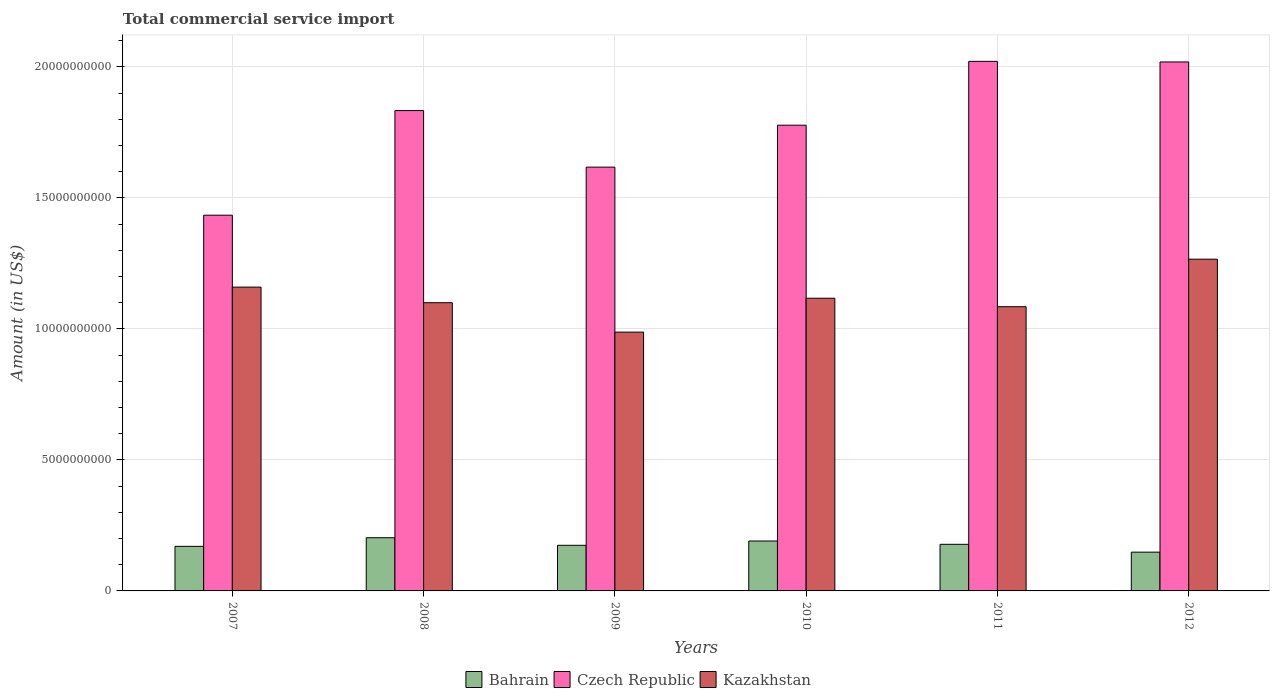How many different coloured bars are there?
Make the answer very short. 3. How many bars are there on the 3rd tick from the left?
Provide a short and direct response. 3. How many bars are there on the 4th tick from the right?
Provide a short and direct response. 3. What is the total commercial service import in Bahrain in 2007?
Provide a succinct answer. 1.70e+09. Across all years, what is the maximum total commercial service import in Czech Republic?
Your answer should be compact. 2.02e+1. Across all years, what is the minimum total commercial service import in Kazakhstan?
Provide a short and direct response. 9.88e+09. In which year was the total commercial service import in Czech Republic maximum?
Your response must be concise. 2011. In which year was the total commercial service import in Bahrain minimum?
Offer a very short reply. 2012. What is the total total commercial service import in Czech Republic in the graph?
Make the answer very short. 1.07e+11. What is the difference between the total commercial service import in Kazakhstan in 2008 and that in 2010?
Your answer should be compact. -1.71e+08. What is the difference between the total commercial service import in Kazakhstan in 2008 and the total commercial service import in Bahrain in 2009?
Your answer should be compact. 9.26e+09. What is the average total commercial service import in Kazakhstan per year?
Provide a short and direct response. 1.12e+1. In the year 2007, what is the difference between the total commercial service import in Czech Republic and total commercial service import in Kazakhstan?
Offer a very short reply. 2.75e+09. What is the ratio of the total commercial service import in Bahrain in 2008 to that in 2012?
Your response must be concise. 1.37. Is the total commercial service import in Kazakhstan in 2007 less than that in 2009?
Keep it short and to the point. No. What is the difference between the highest and the second highest total commercial service import in Bahrain?
Provide a succinct answer. 1.25e+08. What is the difference between the highest and the lowest total commercial service import in Kazakhstan?
Your answer should be compact. 2.78e+09. In how many years, is the total commercial service import in Bahrain greater than the average total commercial service import in Bahrain taken over all years?
Ensure brevity in your answer.  3. What does the 2nd bar from the left in 2010 represents?
Offer a very short reply. Czech Republic. What does the 1st bar from the right in 2012 represents?
Your answer should be compact. Kazakhstan. How many years are there in the graph?
Make the answer very short. 6. Are the values on the major ticks of Y-axis written in scientific E-notation?
Give a very brief answer. No. How many legend labels are there?
Your answer should be compact. 3. What is the title of the graph?
Give a very brief answer. Total commercial service import. Does "Nigeria" appear as one of the legend labels in the graph?
Your answer should be very brief. No. What is the label or title of the X-axis?
Make the answer very short. Years. What is the Amount (in US$) of Bahrain in 2007?
Give a very brief answer. 1.70e+09. What is the Amount (in US$) of Czech Republic in 2007?
Ensure brevity in your answer.  1.43e+1. What is the Amount (in US$) of Kazakhstan in 2007?
Make the answer very short. 1.16e+1. What is the Amount (in US$) in Bahrain in 2008?
Your answer should be compact. 2.03e+09. What is the Amount (in US$) in Czech Republic in 2008?
Offer a terse response. 1.83e+1. What is the Amount (in US$) in Kazakhstan in 2008?
Your answer should be compact. 1.10e+1. What is the Amount (in US$) in Bahrain in 2009?
Provide a short and direct response. 1.74e+09. What is the Amount (in US$) in Czech Republic in 2009?
Your response must be concise. 1.62e+1. What is the Amount (in US$) of Kazakhstan in 2009?
Your answer should be very brief. 9.88e+09. What is the Amount (in US$) in Bahrain in 2010?
Your response must be concise. 1.91e+09. What is the Amount (in US$) in Czech Republic in 2010?
Offer a terse response. 1.78e+1. What is the Amount (in US$) in Kazakhstan in 2010?
Keep it short and to the point. 1.12e+1. What is the Amount (in US$) of Bahrain in 2011?
Offer a terse response. 1.78e+09. What is the Amount (in US$) in Czech Republic in 2011?
Your response must be concise. 2.02e+1. What is the Amount (in US$) of Kazakhstan in 2011?
Provide a succinct answer. 1.08e+1. What is the Amount (in US$) of Bahrain in 2012?
Your answer should be very brief. 1.48e+09. What is the Amount (in US$) of Czech Republic in 2012?
Your answer should be very brief. 2.02e+1. What is the Amount (in US$) in Kazakhstan in 2012?
Offer a terse response. 1.27e+1. Across all years, what is the maximum Amount (in US$) in Bahrain?
Provide a succinct answer. 2.03e+09. Across all years, what is the maximum Amount (in US$) of Czech Republic?
Your answer should be compact. 2.02e+1. Across all years, what is the maximum Amount (in US$) in Kazakhstan?
Keep it short and to the point. 1.27e+1. Across all years, what is the minimum Amount (in US$) of Bahrain?
Your answer should be compact. 1.48e+09. Across all years, what is the minimum Amount (in US$) in Czech Republic?
Provide a succinct answer. 1.43e+1. Across all years, what is the minimum Amount (in US$) of Kazakhstan?
Your response must be concise. 9.88e+09. What is the total Amount (in US$) of Bahrain in the graph?
Ensure brevity in your answer.  1.06e+1. What is the total Amount (in US$) in Czech Republic in the graph?
Give a very brief answer. 1.07e+11. What is the total Amount (in US$) of Kazakhstan in the graph?
Offer a very short reply. 6.72e+1. What is the difference between the Amount (in US$) in Bahrain in 2007 and that in 2008?
Your answer should be compact. -3.29e+08. What is the difference between the Amount (in US$) in Czech Republic in 2007 and that in 2008?
Your answer should be very brief. -3.99e+09. What is the difference between the Amount (in US$) of Kazakhstan in 2007 and that in 2008?
Offer a terse response. 5.95e+08. What is the difference between the Amount (in US$) in Bahrain in 2007 and that in 2009?
Ensure brevity in your answer.  -4.00e+07. What is the difference between the Amount (in US$) of Czech Republic in 2007 and that in 2009?
Provide a succinct answer. -1.83e+09. What is the difference between the Amount (in US$) of Kazakhstan in 2007 and that in 2009?
Give a very brief answer. 1.72e+09. What is the difference between the Amount (in US$) of Bahrain in 2007 and that in 2010?
Give a very brief answer. -2.04e+08. What is the difference between the Amount (in US$) of Czech Republic in 2007 and that in 2010?
Ensure brevity in your answer.  -3.43e+09. What is the difference between the Amount (in US$) in Kazakhstan in 2007 and that in 2010?
Make the answer very short. 4.24e+08. What is the difference between the Amount (in US$) of Bahrain in 2007 and that in 2011?
Provide a short and direct response. -7.75e+07. What is the difference between the Amount (in US$) in Czech Republic in 2007 and that in 2011?
Your answer should be very brief. -5.87e+09. What is the difference between the Amount (in US$) of Kazakhstan in 2007 and that in 2011?
Your answer should be compact. 7.47e+08. What is the difference between the Amount (in US$) in Bahrain in 2007 and that in 2012?
Offer a terse response. 2.21e+08. What is the difference between the Amount (in US$) in Czech Republic in 2007 and that in 2012?
Provide a succinct answer. -5.85e+09. What is the difference between the Amount (in US$) of Kazakhstan in 2007 and that in 2012?
Ensure brevity in your answer.  -1.07e+09. What is the difference between the Amount (in US$) in Bahrain in 2008 and that in 2009?
Provide a short and direct response. 2.89e+08. What is the difference between the Amount (in US$) of Czech Republic in 2008 and that in 2009?
Your response must be concise. 2.16e+09. What is the difference between the Amount (in US$) in Kazakhstan in 2008 and that in 2009?
Give a very brief answer. 1.12e+09. What is the difference between the Amount (in US$) of Bahrain in 2008 and that in 2010?
Provide a short and direct response. 1.25e+08. What is the difference between the Amount (in US$) of Czech Republic in 2008 and that in 2010?
Your answer should be very brief. 5.58e+08. What is the difference between the Amount (in US$) in Kazakhstan in 2008 and that in 2010?
Make the answer very short. -1.71e+08. What is the difference between the Amount (in US$) of Bahrain in 2008 and that in 2011?
Your response must be concise. 2.52e+08. What is the difference between the Amount (in US$) in Czech Republic in 2008 and that in 2011?
Offer a terse response. -1.88e+09. What is the difference between the Amount (in US$) of Kazakhstan in 2008 and that in 2011?
Your response must be concise. 1.52e+08. What is the difference between the Amount (in US$) in Bahrain in 2008 and that in 2012?
Your answer should be compact. 5.50e+08. What is the difference between the Amount (in US$) of Czech Republic in 2008 and that in 2012?
Keep it short and to the point. -1.86e+09. What is the difference between the Amount (in US$) of Kazakhstan in 2008 and that in 2012?
Offer a very short reply. -1.66e+09. What is the difference between the Amount (in US$) in Bahrain in 2009 and that in 2010?
Provide a succinct answer. -1.64e+08. What is the difference between the Amount (in US$) in Czech Republic in 2009 and that in 2010?
Make the answer very short. -1.60e+09. What is the difference between the Amount (in US$) in Kazakhstan in 2009 and that in 2010?
Provide a succinct answer. -1.29e+09. What is the difference between the Amount (in US$) in Bahrain in 2009 and that in 2011?
Your response must be concise. -3.75e+07. What is the difference between the Amount (in US$) in Czech Republic in 2009 and that in 2011?
Make the answer very short. -4.04e+09. What is the difference between the Amount (in US$) in Kazakhstan in 2009 and that in 2011?
Offer a terse response. -9.71e+08. What is the difference between the Amount (in US$) in Bahrain in 2009 and that in 2012?
Make the answer very short. 2.61e+08. What is the difference between the Amount (in US$) of Czech Republic in 2009 and that in 2012?
Offer a terse response. -4.01e+09. What is the difference between the Amount (in US$) of Kazakhstan in 2009 and that in 2012?
Give a very brief answer. -2.78e+09. What is the difference between the Amount (in US$) of Bahrain in 2010 and that in 2011?
Your response must be concise. 1.27e+08. What is the difference between the Amount (in US$) in Czech Republic in 2010 and that in 2011?
Give a very brief answer. -2.44e+09. What is the difference between the Amount (in US$) in Kazakhstan in 2010 and that in 2011?
Your response must be concise. 3.23e+08. What is the difference between the Amount (in US$) in Bahrain in 2010 and that in 2012?
Make the answer very short. 4.25e+08. What is the difference between the Amount (in US$) in Czech Republic in 2010 and that in 2012?
Give a very brief answer. -2.41e+09. What is the difference between the Amount (in US$) in Kazakhstan in 2010 and that in 2012?
Your answer should be very brief. -1.49e+09. What is the difference between the Amount (in US$) in Bahrain in 2011 and that in 2012?
Offer a very short reply. 2.98e+08. What is the difference between the Amount (in US$) of Czech Republic in 2011 and that in 2012?
Give a very brief answer. 2.30e+07. What is the difference between the Amount (in US$) of Kazakhstan in 2011 and that in 2012?
Your response must be concise. -1.81e+09. What is the difference between the Amount (in US$) of Bahrain in 2007 and the Amount (in US$) of Czech Republic in 2008?
Your answer should be very brief. -1.66e+1. What is the difference between the Amount (in US$) in Bahrain in 2007 and the Amount (in US$) in Kazakhstan in 2008?
Your answer should be compact. -9.30e+09. What is the difference between the Amount (in US$) of Czech Republic in 2007 and the Amount (in US$) of Kazakhstan in 2008?
Make the answer very short. 3.34e+09. What is the difference between the Amount (in US$) in Bahrain in 2007 and the Amount (in US$) in Czech Republic in 2009?
Keep it short and to the point. -1.45e+1. What is the difference between the Amount (in US$) in Bahrain in 2007 and the Amount (in US$) in Kazakhstan in 2009?
Give a very brief answer. -8.18e+09. What is the difference between the Amount (in US$) in Czech Republic in 2007 and the Amount (in US$) in Kazakhstan in 2009?
Make the answer very short. 4.46e+09. What is the difference between the Amount (in US$) in Bahrain in 2007 and the Amount (in US$) in Czech Republic in 2010?
Offer a terse response. -1.61e+1. What is the difference between the Amount (in US$) of Bahrain in 2007 and the Amount (in US$) of Kazakhstan in 2010?
Keep it short and to the point. -9.47e+09. What is the difference between the Amount (in US$) in Czech Republic in 2007 and the Amount (in US$) in Kazakhstan in 2010?
Keep it short and to the point. 3.17e+09. What is the difference between the Amount (in US$) in Bahrain in 2007 and the Amount (in US$) in Czech Republic in 2011?
Give a very brief answer. -1.85e+1. What is the difference between the Amount (in US$) of Bahrain in 2007 and the Amount (in US$) of Kazakhstan in 2011?
Your answer should be very brief. -9.15e+09. What is the difference between the Amount (in US$) of Czech Republic in 2007 and the Amount (in US$) of Kazakhstan in 2011?
Ensure brevity in your answer.  3.49e+09. What is the difference between the Amount (in US$) of Bahrain in 2007 and the Amount (in US$) of Czech Republic in 2012?
Your response must be concise. -1.85e+1. What is the difference between the Amount (in US$) of Bahrain in 2007 and the Amount (in US$) of Kazakhstan in 2012?
Your response must be concise. -1.10e+1. What is the difference between the Amount (in US$) in Czech Republic in 2007 and the Amount (in US$) in Kazakhstan in 2012?
Keep it short and to the point. 1.68e+09. What is the difference between the Amount (in US$) in Bahrain in 2008 and the Amount (in US$) in Czech Republic in 2009?
Your answer should be very brief. -1.41e+1. What is the difference between the Amount (in US$) of Bahrain in 2008 and the Amount (in US$) of Kazakhstan in 2009?
Provide a succinct answer. -7.85e+09. What is the difference between the Amount (in US$) of Czech Republic in 2008 and the Amount (in US$) of Kazakhstan in 2009?
Offer a very short reply. 8.46e+09. What is the difference between the Amount (in US$) of Bahrain in 2008 and the Amount (in US$) of Czech Republic in 2010?
Provide a short and direct response. -1.57e+1. What is the difference between the Amount (in US$) in Bahrain in 2008 and the Amount (in US$) in Kazakhstan in 2010?
Provide a short and direct response. -9.14e+09. What is the difference between the Amount (in US$) of Czech Republic in 2008 and the Amount (in US$) of Kazakhstan in 2010?
Offer a very short reply. 7.16e+09. What is the difference between the Amount (in US$) of Bahrain in 2008 and the Amount (in US$) of Czech Republic in 2011?
Provide a succinct answer. -1.82e+1. What is the difference between the Amount (in US$) in Bahrain in 2008 and the Amount (in US$) in Kazakhstan in 2011?
Provide a succinct answer. -8.82e+09. What is the difference between the Amount (in US$) of Czech Republic in 2008 and the Amount (in US$) of Kazakhstan in 2011?
Offer a very short reply. 7.49e+09. What is the difference between the Amount (in US$) of Bahrain in 2008 and the Amount (in US$) of Czech Republic in 2012?
Your response must be concise. -1.82e+1. What is the difference between the Amount (in US$) in Bahrain in 2008 and the Amount (in US$) in Kazakhstan in 2012?
Your response must be concise. -1.06e+1. What is the difference between the Amount (in US$) of Czech Republic in 2008 and the Amount (in US$) of Kazakhstan in 2012?
Your answer should be compact. 5.67e+09. What is the difference between the Amount (in US$) in Bahrain in 2009 and the Amount (in US$) in Czech Republic in 2010?
Your response must be concise. -1.60e+1. What is the difference between the Amount (in US$) in Bahrain in 2009 and the Amount (in US$) in Kazakhstan in 2010?
Keep it short and to the point. -9.43e+09. What is the difference between the Amount (in US$) in Czech Republic in 2009 and the Amount (in US$) in Kazakhstan in 2010?
Provide a short and direct response. 5.00e+09. What is the difference between the Amount (in US$) in Bahrain in 2009 and the Amount (in US$) in Czech Republic in 2011?
Make the answer very short. -1.85e+1. What is the difference between the Amount (in US$) of Bahrain in 2009 and the Amount (in US$) of Kazakhstan in 2011?
Provide a short and direct response. -9.11e+09. What is the difference between the Amount (in US$) of Czech Republic in 2009 and the Amount (in US$) of Kazakhstan in 2011?
Provide a succinct answer. 5.33e+09. What is the difference between the Amount (in US$) in Bahrain in 2009 and the Amount (in US$) in Czech Republic in 2012?
Offer a terse response. -1.84e+1. What is the difference between the Amount (in US$) of Bahrain in 2009 and the Amount (in US$) of Kazakhstan in 2012?
Your answer should be very brief. -1.09e+1. What is the difference between the Amount (in US$) in Czech Republic in 2009 and the Amount (in US$) in Kazakhstan in 2012?
Ensure brevity in your answer.  3.51e+09. What is the difference between the Amount (in US$) of Bahrain in 2010 and the Amount (in US$) of Czech Republic in 2011?
Offer a terse response. -1.83e+1. What is the difference between the Amount (in US$) in Bahrain in 2010 and the Amount (in US$) in Kazakhstan in 2011?
Your answer should be compact. -8.94e+09. What is the difference between the Amount (in US$) of Czech Republic in 2010 and the Amount (in US$) of Kazakhstan in 2011?
Offer a very short reply. 6.93e+09. What is the difference between the Amount (in US$) of Bahrain in 2010 and the Amount (in US$) of Czech Republic in 2012?
Make the answer very short. -1.83e+1. What is the difference between the Amount (in US$) of Bahrain in 2010 and the Amount (in US$) of Kazakhstan in 2012?
Offer a terse response. -1.08e+1. What is the difference between the Amount (in US$) in Czech Republic in 2010 and the Amount (in US$) in Kazakhstan in 2012?
Make the answer very short. 5.11e+09. What is the difference between the Amount (in US$) in Bahrain in 2011 and the Amount (in US$) in Czech Republic in 2012?
Offer a very short reply. -1.84e+1. What is the difference between the Amount (in US$) of Bahrain in 2011 and the Amount (in US$) of Kazakhstan in 2012?
Your response must be concise. -1.09e+1. What is the difference between the Amount (in US$) of Czech Republic in 2011 and the Amount (in US$) of Kazakhstan in 2012?
Provide a succinct answer. 7.55e+09. What is the average Amount (in US$) of Bahrain per year?
Offer a very short reply. 1.77e+09. What is the average Amount (in US$) of Czech Republic per year?
Offer a very short reply. 1.78e+1. What is the average Amount (in US$) of Kazakhstan per year?
Keep it short and to the point. 1.12e+1. In the year 2007, what is the difference between the Amount (in US$) of Bahrain and Amount (in US$) of Czech Republic?
Your response must be concise. -1.26e+1. In the year 2007, what is the difference between the Amount (in US$) of Bahrain and Amount (in US$) of Kazakhstan?
Keep it short and to the point. -9.89e+09. In the year 2007, what is the difference between the Amount (in US$) of Czech Republic and Amount (in US$) of Kazakhstan?
Ensure brevity in your answer.  2.75e+09. In the year 2008, what is the difference between the Amount (in US$) in Bahrain and Amount (in US$) in Czech Republic?
Your answer should be compact. -1.63e+1. In the year 2008, what is the difference between the Amount (in US$) in Bahrain and Amount (in US$) in Kazakhstan?
Your response must be concise. -8.97e+09. In the year 2008, what is the difference between the Amount (in US$) of Czech Republic and Amount (in US$) of Kazakhstan?
Offer a terse response. 7.33e+09. In the year 2009, what is the difference between the Amount (in US$) in Bahrain and Amount (in US$) in Czech Republic?
Ensure brevity in your answer.  -1.44e+1. In the year 2009, what is the difference between the Amount (in US$) in Bahrain and Amount (in US$) in Kazakhstan?
Your answer should be very brief. -8.14e+09. In the year 2009, what is the difference between the Amount (in US$) of Czech Republic and Amount (in US$) of Kazakhstan?
Keep it short and to the point. 6.30e+09. In the year 2010, what is the difference between the Amount (in US$) in Bahrain and Amount (in US$) in Czech Republic?
Your answer should be very brief. -1.59e+1. In the year 2010, what is the difference between the Amount (in US$) of Bahrain and Amount (in US$) of Kazakhstan?
Your response must be concise. -9.27e+09. In the year 2010, what is the difference between the Amount (in US$) in Czech Republic and Amount (in US$) in Kazakhstan?
Provide a succinct answer. 6.60e+09. In the year 2011, what is the difference between the Amount (in US$) of Bahrain and Amount (in US$) of Czech Republic?
Offer a very short reply. -1.84e+1. In the year 2011, what is the difference between the Amount (in US$) of Bahrain and Amount (in US$) of Kazakhstan?
Provide a succinct answer. -9.07e+09. In the year 2011, what is the difference between the Amount (in US$) in Czech Republic and Amount (in US$) in Kazakhstan?
Your answer should be compact. 9.36e+09. In the year 2012, what is the difference between the Amount (in US$) of Bahrain and Amount (in US$) of Czech Republic?
Provide a short and direct response. -1.87e+1. In the year 2012, what is the difference between the Amount (in US$) in Bahrain and Amount (in US$) in Kazakhstan?
Give a very brief answer. -1.12e+1. In the year 2012, what is the difference between the Amount (in US$) of Czech Republic and Amount (in US$) of Kazakhstan?
Your answer should be very brief. 7.53e+09. What is the ratio of the Amount (in US$) in Bahrain in 2007 to that in 2008?
Keep it short and to the point. 0.84. What is the ratio of the Amount (in US$) in Czech Republic in 2007 to that in 2008?
Give a very brief answer. 0.78. What is the ratio of the Amount (in US$) of Kazakhstan in 2007 to that in 2008?
Offer a very short reply. 1.05. What is the ratio of the Amount (in US$) of Czech Republic in 2007 to that in 2009?
Make the answer very short. 0.89. What is the ratio of the Amount (in US$) of Kazakhstan in 2007 to that in 2009?
Give a very brief answer. 1.17. What is the ratio of the Amount (in US$) in Bahrain in 2007 to that in 2010?
Provide a succinct answer. 0.89. What is the ratio of the Amount (in US$) of Czech Republic in 2007 to that in 2010?
Your answer should be compact. 0.81. What is the ratio of the Amount (in US$) in Kazakhstan in 2007 to that in 2010?
Your answer should be very brief. 1.04. What is the ratio of the Amount (in US$) in Bahrain in 2007 to that in 2011?
Ensure brevity in your answer.  0.96. What is the ratio of the Amount (in US$) of Czech Republic in 2007 to that in 2011?
Provide a succinct answer. 0.71. What is the ratio of the Amount (in US$) of Kazakhstan in 2007 to that in 2011?
Give a very brief answer. 1.07. What is the ratio of the Amount (in US$) in Bahrain in 2007 to that in 2012?
Provide a succinct answer. 1.15. What is the ratio of the Amount (in US$) of Czech Republic in 2007 to that in 2012?
Provide a short and direct response. 0.71. What is the ratio of the Amount (in US$) in Kazakhstan in 2007 to that in 2012?
Your response must be concise. 0.92. What is the ratio of the Amount (in US$) of Bahrain in 2008 to that in 2009?
Your answer should be very brief. 1.17. What is the ratio of the Amount (in US$) in Czech Republic in 2008 to that in 2009?
Give a very brief answer. 1.13. What is the ratio of the Amount (in US$) of Kazakhstan in 2008 to that in 2009?
Provide a succinct answer. 1.11. What is the ratio of the Amount (in US$) of Bahrain in 2008 to that in 2010?
Keep it short and to the point. 1.07. What is the ratio of the Amount (in US$) of Czech Republic in 2008 to that in 2010?
Provide a short and direct response. 1.03. What is the ratio of the Amount (in US$) in Kazakhstan in 2008 to that in 2010?
Give a very brief answer. 0.98. What is the ratio of the Amount (in US$) in Bahrain in 2008 to that in 2011?
Provide a short and direct response. 1.14. What is the ratio of the Amount (in US$) of Czech Republic in 2008 to that in 2011?
Give a very brief answer. 0.91. What is the ratio of the Amount (in US$) in Bahrain in 2008 to that in 2012?
Your response must be concise. 1.37. What is the ratio of the Amount (in US$) in Czech Republic in 2008 to that in 2012?
Make the answer very short. 0.91. What is the ratio of the Amount (in US$) in Kazakhstan in 2008 to that in 2012?
Make the answer very short. 0.87. What is the ratio of the Amount (in US$) of Bahrain in 2009 to that in 2010?
Offer a very short reply. 0.91. What is the ratio of the Amount (in US$) of Czech Republic in 2009 to that in 2010?
Keep it short and to the point. 0.91. What is the ratio of the Amount (in US$) of Kazakhstan in 2009 to that in 2010?
Offer a terse response. 0.88. What is the ratio of the Amount (in US$) in Bahrain in 2009 to that in 2011?
Give a very brief answer. 0.98. What is the ratio of the Amount (in US$) of Czech Republic in 2009 to that in 2011?
Your response must be concise. 0.8. What is the ratio of the Amount (in US$) of Kazakhstan in 2009 to that in 2011?
Offer a very short reply. 0.91. What is the ratio of the Amount (in US$) of Bahrain in 2009 to that in 2012?
Your response must be concise. 1.18. What is the ratio of the Amount (in US$) of Czech Republic in 2009 to that in 2012?
Provide a succinct answer. 0.8. What is the ratio of the Amount (in US$) of Kazakhstan in 2009 to that in 2012?
Your response must be concise. 0.78. What is the ratio of the Amount (in US$) of Bahrain in 2010 to that in 2011?
Ensure brevity in your answer.  1.07. What is the ratio of the Amount (in US$) in Czech Republic in 2010 to that in 2011?
Your answer should be very brief. 0.88. What is the ratio of the Amount (in US$) in Kazakhstan in 2010 to that in 2011?
Ensure brevity in your answer.  1.03. What is the ratio of the Amount (in US$) in Bahrain in 2010 to that in 2012?
Provide a short and direct response. 1.29. What is the ratio of the Amount (in US$) of Czech Republic in 2010 to that in 2012?
Your response must be concise. 0.88. What is the ratio of the Amount (in US$) of Kazakhstan in 2010 to that in 2012?
Provide a succinct answer. 0.88. What is the ratio of the Amount (in US$) in Bahrain in 2011 to that in 2012?
Ensure brevity in your answer.  1.2. What is the ratio of the Amount (in US$) of Kazakhstan in 2011 to that in 2012?
Your response must be concise. 0.86. What is the difference between the highest and the second highest Amount (in US$) of Bahrain?
Offer a terse response. 1.25e+08. What is the difference between the highest and the second highest Amount (in US$) in Czech Republic?
Provide a short and direct response. 2.30e+07. What is the difference between the highest and the second highest Amount (in US$) in Kazakhstan?
Your answer should be very brief. 1.07e+09. What is the difference between the highest and the lowest Amount (in US$) in Bahrain?
Give a very brief answer. 5.50e+08. What is the difference between the highest and the lowest Amount (in US$) in Czech Republic?
Ensure brevity in your answer.  5.87e+09. What is the difference between the highest and the lowest Amount (in US$) of Kazakhstan?
Make the answer very short. 2.78e+09. 